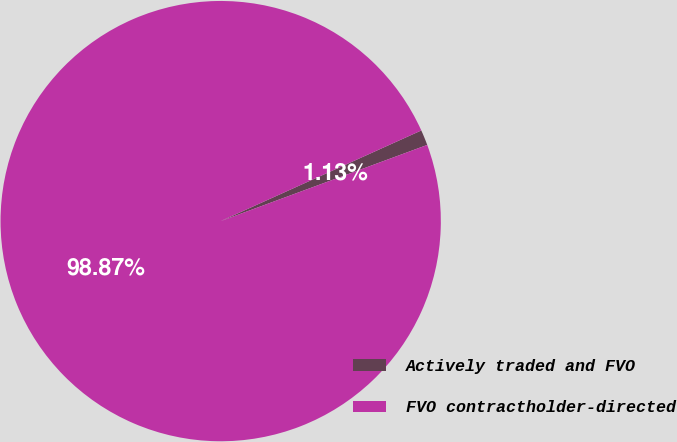Convert chart. <chart><loc_0><loc_0><loc_500><loc_500><pie_chart><fcel>Actively traded and FVO<fcel>FVO contractholder-directed<nl><fcel>1.13%<fcel>98.87%<nl></chart> 